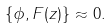<formula> <loc_0><loc_0><loc_500><loc_500>\left \{ \phi , F ( z ) \right \} \approx 0 .</formula> 